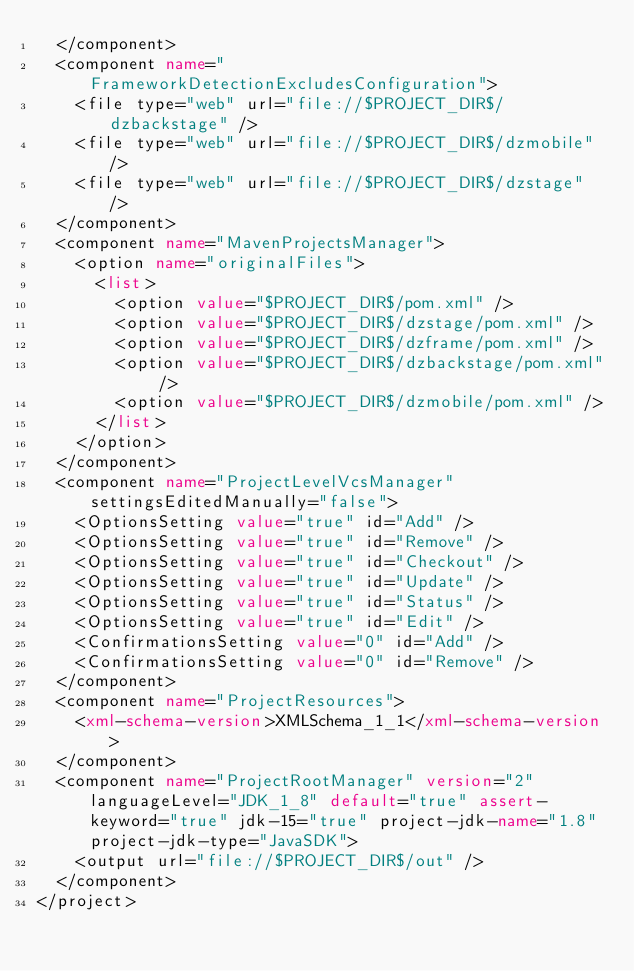Convert code to text. <code><loc_0><loc_0><loc_500><loc_500><_XML_>  </component>
  <component name="FrameworkDetectionExcludesConfiguration">
    <file type="web" url="file://$PROJECT_DIR$/dzbackstage" />
    <file type="web" url="file://$PROJECT_DIR$/dzmobile" />
    <file type="web" url="file://$PROJECT_DIR$/dzstage" />
  </component>
  <component name="MavenProjectsManager">
    <option name="originalFiles">
      <list>
        <option value="$PROJECT_DIR$/pom.xml" />
        <option value="$PROJECT_DIR$/dzstage/pom.xml" />
        <option value="$PROJECT_DIR$/dzframe/pom.xml" />
        <option value="$PROJECT_DIR$/dzbackstage/pom.xml" />
        <option value="$PROJECT_DIR$/dzmobile/pom.xml" />
      </list>
    </option>
  </component>
  <component name="ProjectLevelVcsManager" settingsEditedManually="false">
    <OptionsSetting value="true" id="Add" />
    <OptionsSetting value="true" id="Remove" />
    <OptionsSetting value="true" id="Checkout" />
    <OptionsSetting value="true" id="Update" />
    <OptionsSetting value="true" id="Status" />
    <OptionsSetting value="true" id="Edit" />
    <ConfirmationsSetting value="0" id="Add" />
    <ConfirmationsSetting value="0" id="Remove" />
  </component>
  <component name="ProjectResources">
    <xml-schema-version>XMLSchema_1_1</xml-schema-version>
  </component>
  <component name="ProjectRootManager" version="2" languageLevel="JDK_1_8" default="true" assert-keyword="true" jdk-15="true" project-jdk-name="1.8" project-jdk-type="JavaSDK">
    <output url="file://$PROJECT_DIR$/out" />
  </component>
</project></code> 